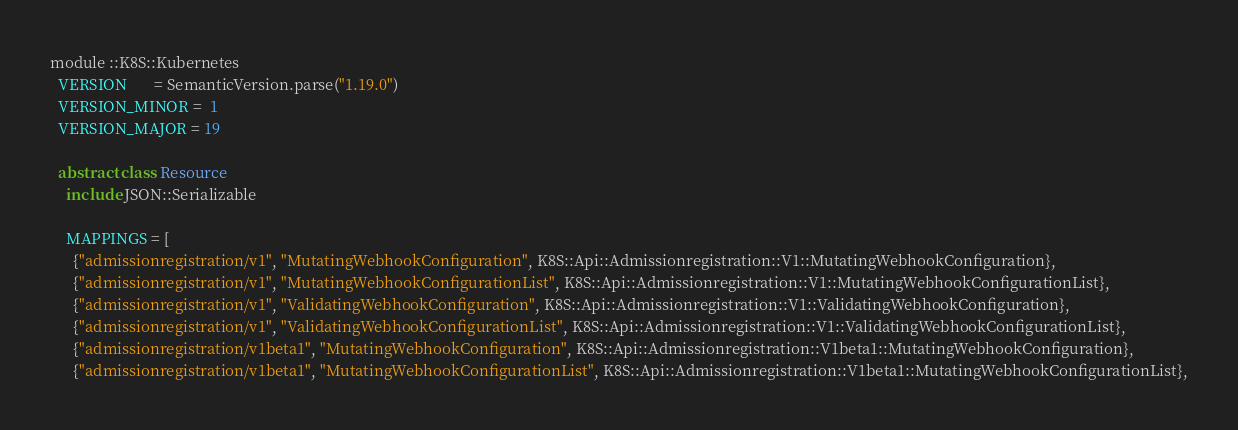Convert code to text. <code><loc_0><loc_0><loc_500><loc_500><_Crystal_>module ::K8S::Kubernetes
  VERSION       = SemanticVersion.parse("1.19.0")
  VERSION_MINOR =  1
  VERSION_MAJOR = 19

  abstract class Resource
    include JSON::Serializable

    MAPPINGS = [
      {"admissionregistration/v1", "MutatingWebhookConfiguration", K8S::Api::Admissionregistration::V1::MutatingWebhookConfiguration},
      {"admissionregistration/v1", "MutatingWebhookConfigurationList", K8S::Api::Admissionregistration::V1::MutatingWebhookConfigurationList},
      {"admissionregistration/v1", "ValidatingWebhookConfiguration", K8S::Api::Admissionregistration::V1::ValidatingWebhookConfiguration},
      {"admissionregistration/v1", "ValidatingWebhookConfigurationList", K8S::Api::Admissionregistration::V1::ValidatingWebhookConfigurationList},
      {"admissionregistration/v1beta1", "MutatingWebhookConfiguration", K8S::Api::Admissionregistration::V1beta1::MutatingWebhookConfiguration},
      {"admissionregistration/v1beta1", "MutatingWebhookConfigurationList", K8S::Api::Admissionregistration::V1beta1::MutatingWebhookConfigurationList},</code> 